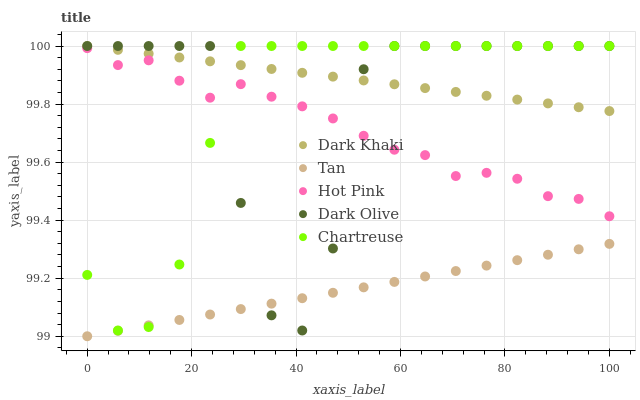Does Tan have the minimum area under the curve?
Answer yes or no. Yes. Does Dark Khaki have the maximum area under the curve?
Answer yes or no. Yes. Does Hot Pink have the minimum area under the curve?
Answer yes or no. No. Does Hot Pink have the maximum area under the curve?
Answer yes or no. No. Is Tan the smoothest?
Answer yes or no. Yes. Is Dark Olive the roughest?
Answer yes or no. Yes. Is Hot Pink the smoothest?
Answer yes or no. No. Is Hot Pink the roughest?
Answer yes or no. No. Does Tan have the lowest value?
Answer yes or no. Yes. Does Hot Pink have the lowest value?
Answer yes or no. No. Does Chartreuse have the highest value?
Answer yes or no. Yes. Does Hot Pink have the highest value?
Answer yes or no. No. Is Hot Pink less than Dark Khaki?
Answer yes or no. Yes. Is Dark Khaki greater than Tan?
Answer yes or no. Yes. Does Dark Khaki intersect Dark Olive?
Answer yes or no. Yes. Is Dark Khaki less than Dark Olive?
Answer yes or no. No. Is Dark Khaki greater than Dark Olive?
Answer yes or no. No. Does Hot Pink intersect Dark Khaki?
Answer yes or no. No. 